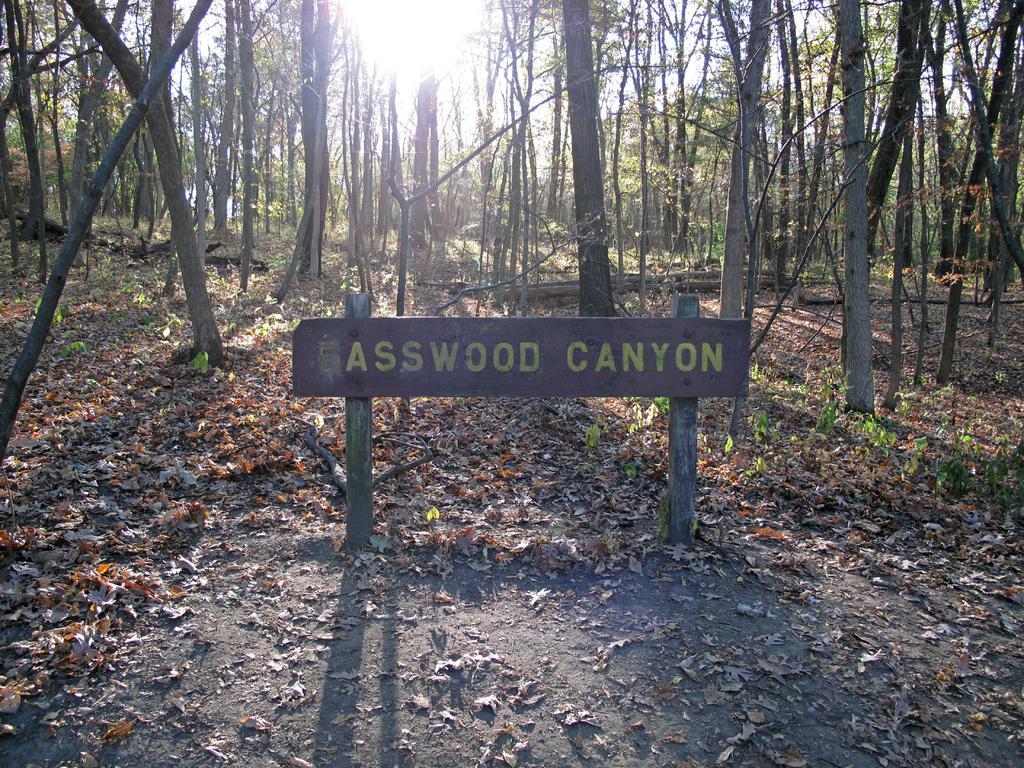Describe this image in one or two sentences. In this image in the center there is one board and wooden sticks, on the board there is text and at the bottom there is sand and some dry leaves and in the background there are trees and sky. 